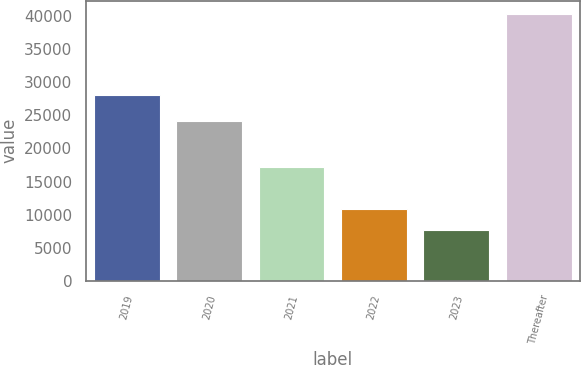Convert chart. <chart><loc_0><loc_0><loc_500><loc_500><bar_chart><fcel>2019<fcel>2020<fcel>2021<fcel>2022<fcel>2023<fcel>Thereafter<nl><fcel>28083<fcel>24115<fcel>17221<fcel>10923.5<fcel>7661<fcel>40286<nl></chart> 